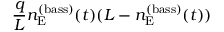Convert formula to latex. <formula><loc_0><loc_0><loc_500><loc_500>\frac { q } { L } n _ { E } ^ { ( b a s s ) } ( t ) ( L - n _ { E } ^ { ( b a s s ) } ( t ) )</formula> 